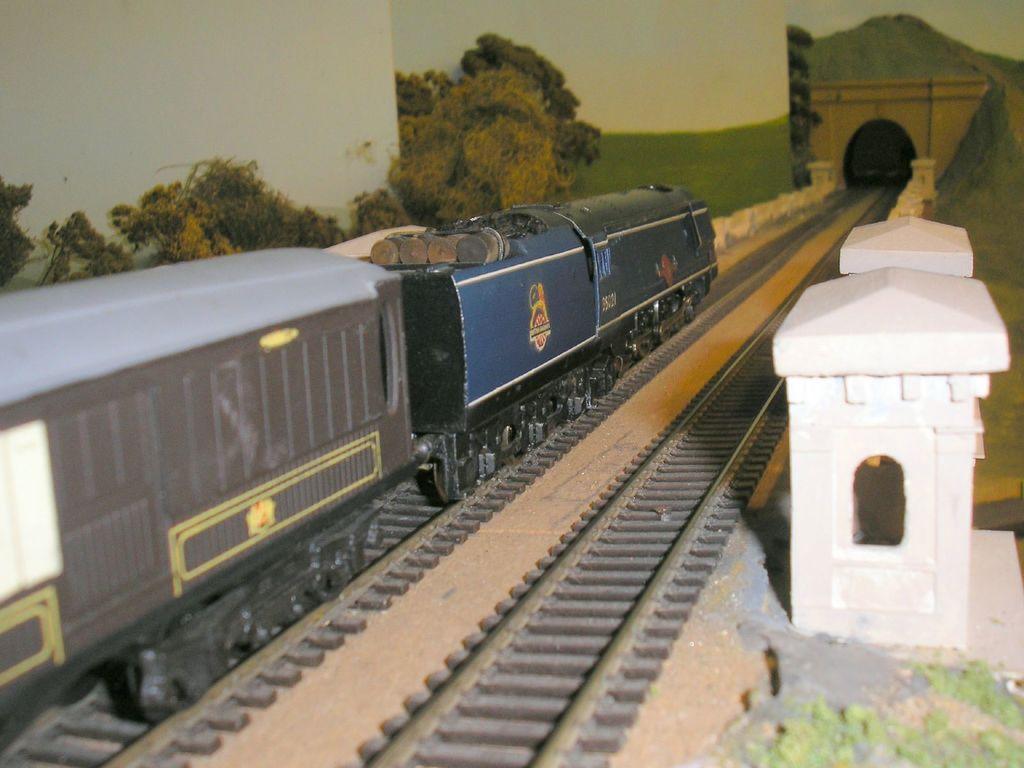Describe this image in one or two sentences. There is a train on a railway track as we can see in the middle of this image, and there are some trees, and a grassy land in the background. There is a tunnel at the top of right side of this image. There is a railway track at the bottom of this image, and there is a white color pole on the right side of this image. 